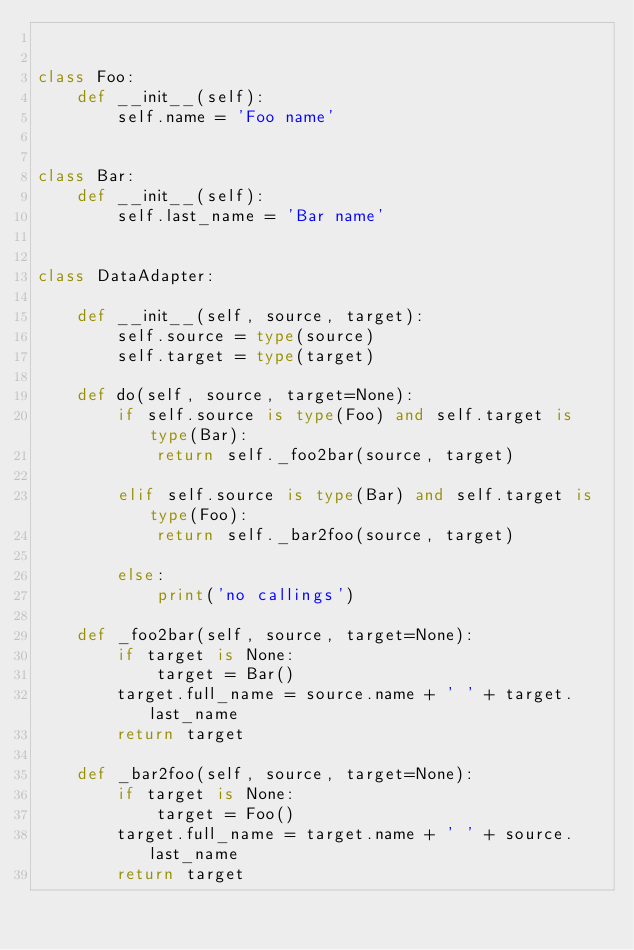Convert code to text. <code><loc_0><loc_0><loc_500><loc_500><_Python_>

class Foo:
    def __init__(self):
        self.name = 'Foo name'


class Bar:
    def __init__(self):
        self.last_name = 'Bar name'


class DataAdapter:

    def __init__(self, source, target):
        self.source = type(source)
        self.target = type(target)

    def do(self, source, target=None):
        if self.source is type(Foo) and self.target is type(Bar):
            return self._foo2bar(source, target)

        elif self.source is type(Bar) and self.target is type(Foo):
            return self._bar2foo(source, target)

        else:
            print('no callings')

    def _foo2bar(self, source, target=None):
        if target is None:
            target = Bar()
        target.full_name = source.name + ' ' + target.last_name
        return target

    def _bar2foo(self, source, target=None):
        if target is None:
            target = Foo()
        target.full_name = target.name + ' ' + source.last_name
        return target
</code> 